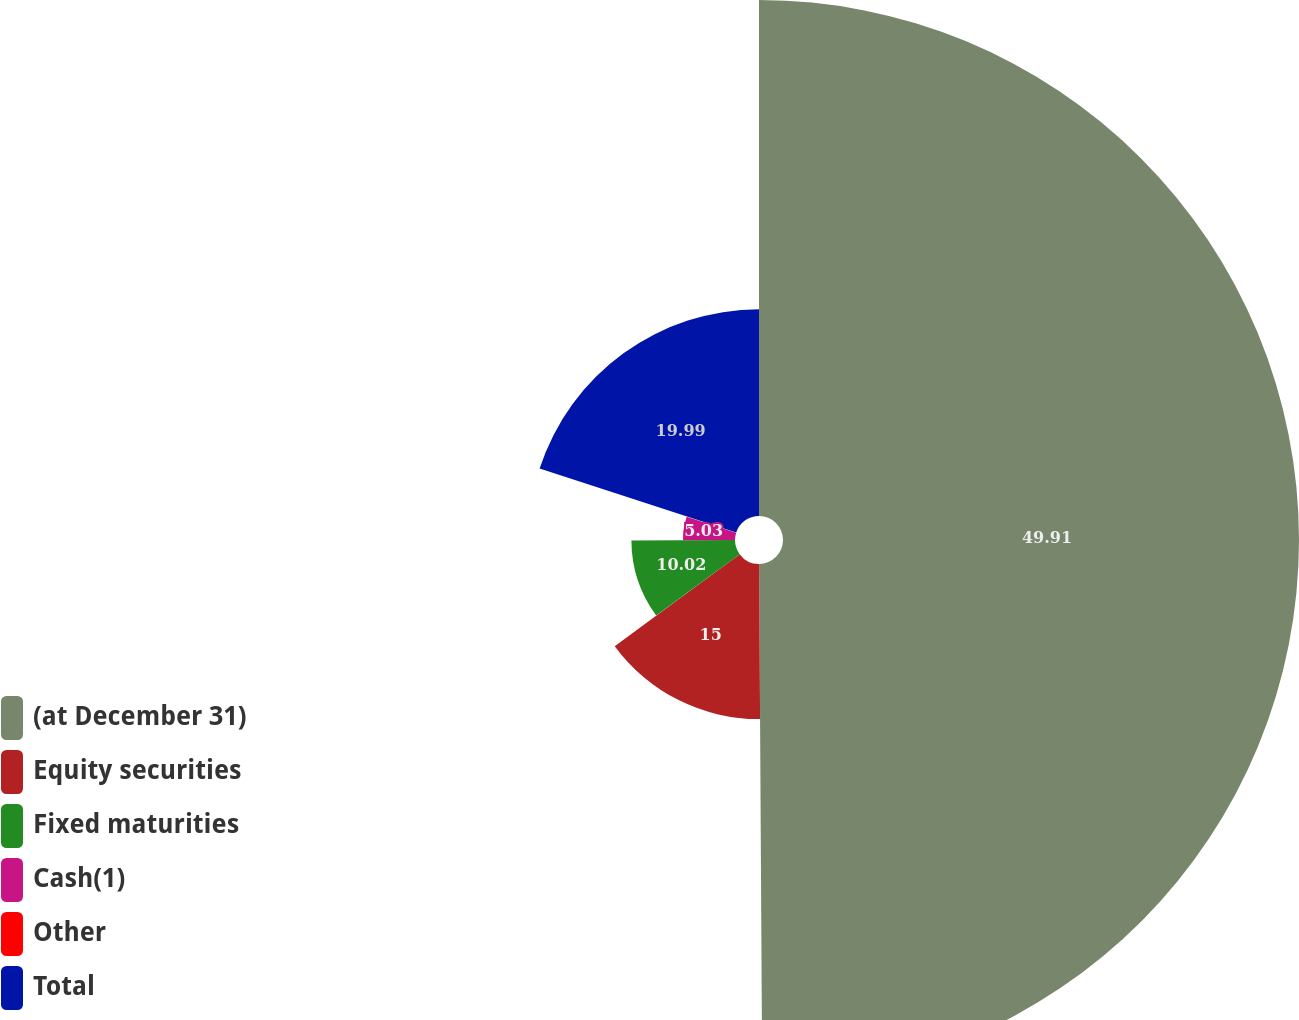Convert chart. <chart><loc_0><loc_0><loc_500><loc_500><pie_chart><fcel>(at December 31)<fcel>Equity securities<fcel>Fixed maturities<fcel>Cash(1)<fcel>Other<fcel>Total<nl><fcel>49.9%<fcel>15.0%<fcel>10.02%<fcel>5.03%<fcel>0.05%<fcel>19.99%<nl></chart> 